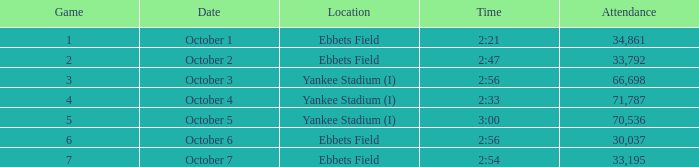The game of 6 has what lowest attendance? 30037.0. 